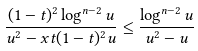<formula> <loc_0><loc_0><loc_500><loc_500>\frac { ( 1 - t ) ^ { 2 } \log ^ { n - 2 } u } { u ^ { 2 } - x t ( 1 - t ) ^ { 2 } u } \leq \frac { \log ^ { n - 2 } u } { u ^ { 2 } - u }</formula> 